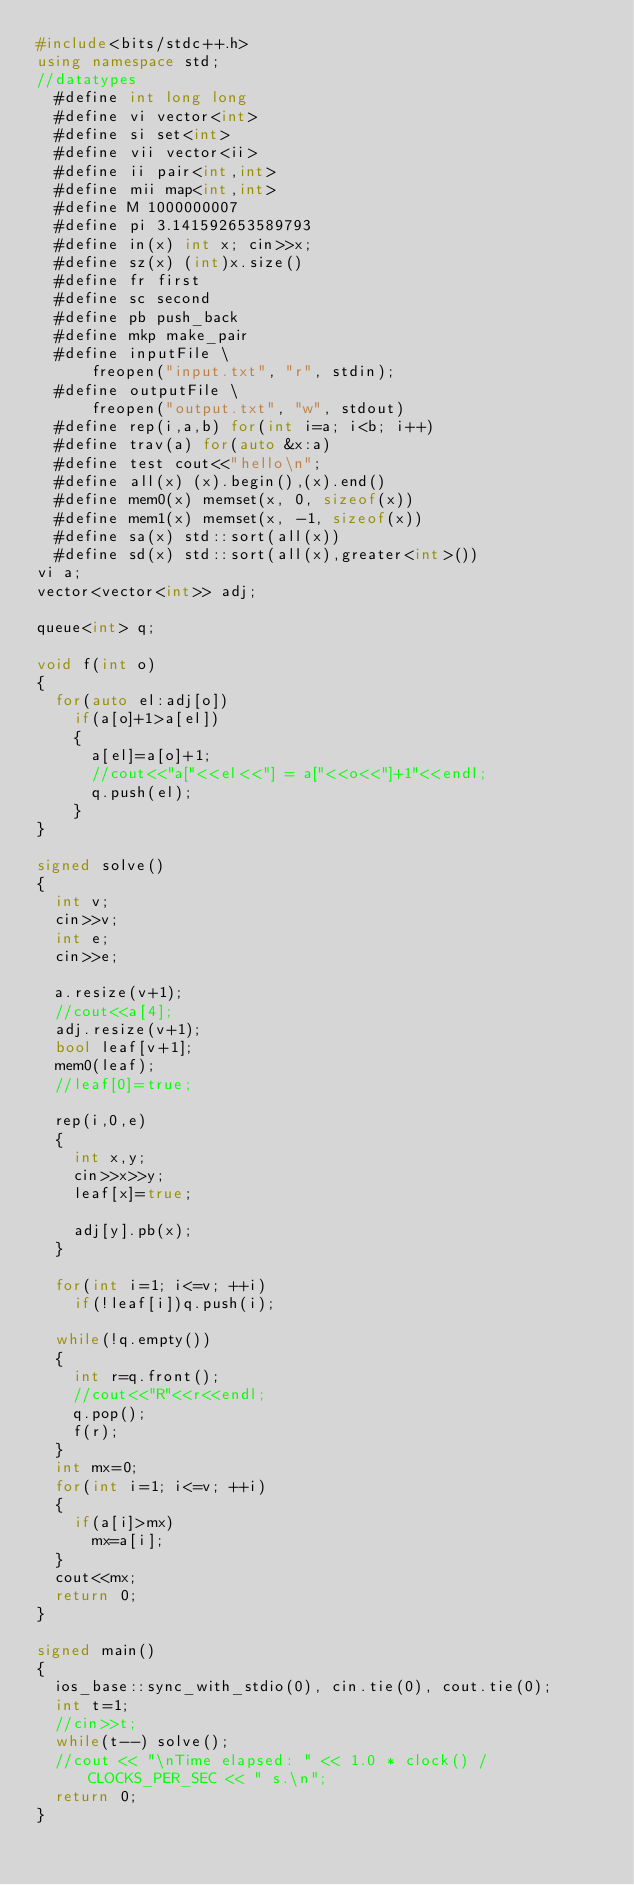<code> <loc_0><loc_0><loc_500><loc_500><_C++_>#include<bits/stdc++.h>
using namespace std;
//datatypes
	#define int long long
	#define vi vector<int>
	#define si set<int>
	#define vii vector<ii>
	#define ii pair<int,int>
	#define mii map<int,int>
	#define M 1000000007
	#define pi 3.141592653589793
	#define in(x) int x; cin>>x;
	#define sz(x) (int)x.size()
	#define fr first
	#define sc second
	#define pb push_back
	#define mkp make_pair
	#define inputFile \
	    freopen("input.txt", "r", stdin); 
	#define outputFile \
	    freopen("output.txt", "w", stdout)
	#define rep(i,a,b) for(int i=a; i<b; i++)
	#define trav(a) for(auto &x:a)
	#define test cout<<"hello\n";
	#define all(x) (x).begin(),(x).end()
	#define mem0(x) memset(x, 0, sizeof(x))
	#define mem1(x) memset(x, -1, sizeof(x))
	#define sa(x) std::sort(all(x))
	#define sd(x) std::sort(all(x),greater<int>())
vi a;
vector<vector<int>> adj;

queue<int> q;

void f(int o)
{
	for(auto el:adj[o])
		if(a[o]+1>a[el])
		{
			a[el]=a[o]+1;
			//cout<<"a["<<el<<"] = a["<<o<<"]+1"<<endl;
			q.push(el);
		}
}

signed solve()
{
	int v;
	cin>>v;
	int e;
	cin>>e;

	a.resize(v+1);
	//cout<<a[4];
	adj.resize(v+1);
	bool leaf[v+1];
	mem0(leaf);
	//leaf[0]=true;

	rep(i,0,e)
	{
		int x,y;
		cin>>x>>y;
		leaf[x]=true;

		adj[y].pb(x);
	}

	for(int i=1; i<=v; ++i)
		if(!leaf[i])q.push(i);

	while(!q.empty())
	{
		int r=q.front();
		//cout<<"R"<<r<<endl;
		q.pop();
		f(r);
	}
	int mx=0;
	for(int i=1; i<=v; ++i)
	{
		if(a[i]>mx)
			mx=a[i];
	}
	cout<<mx;
	return 0;
}

signed main()
{
	ios_base::sync_with_stdio(0), cin.tie(0), cout.tie(0);
	int t=1;
	//cin>>t;
	while(t--) solve();
	//cout << "\nTime elapsed: " << 1.0 * clock() / CLOCKS_PER_SEC << " s.\n";
	return 0;
}</code> 